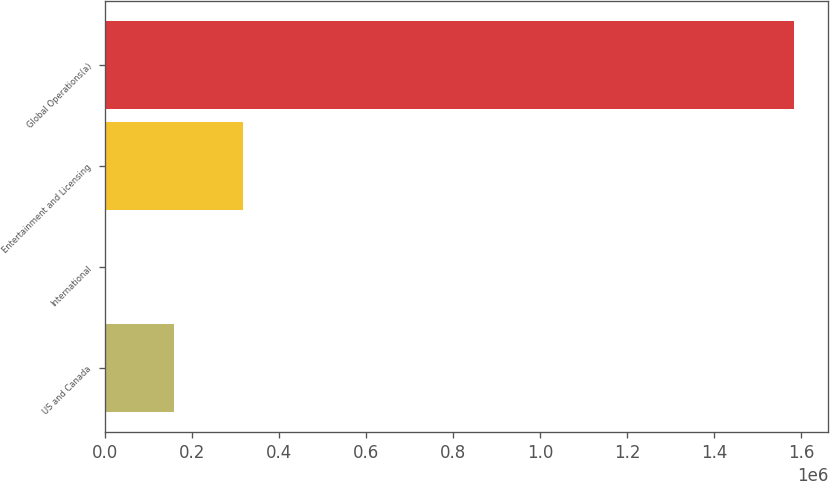Convert chart to OTSL. <chart><loc_0><loc_0><loc_500><loc_500><bar_chart><fcel>US and Canada<fcel>International<fcel>Entertainment and Licensing<fcel>Global Operations(a)<nl><fcel>158380<fcel>15<fcel>316745<fcel>1.58366e+06<nl></chart> 